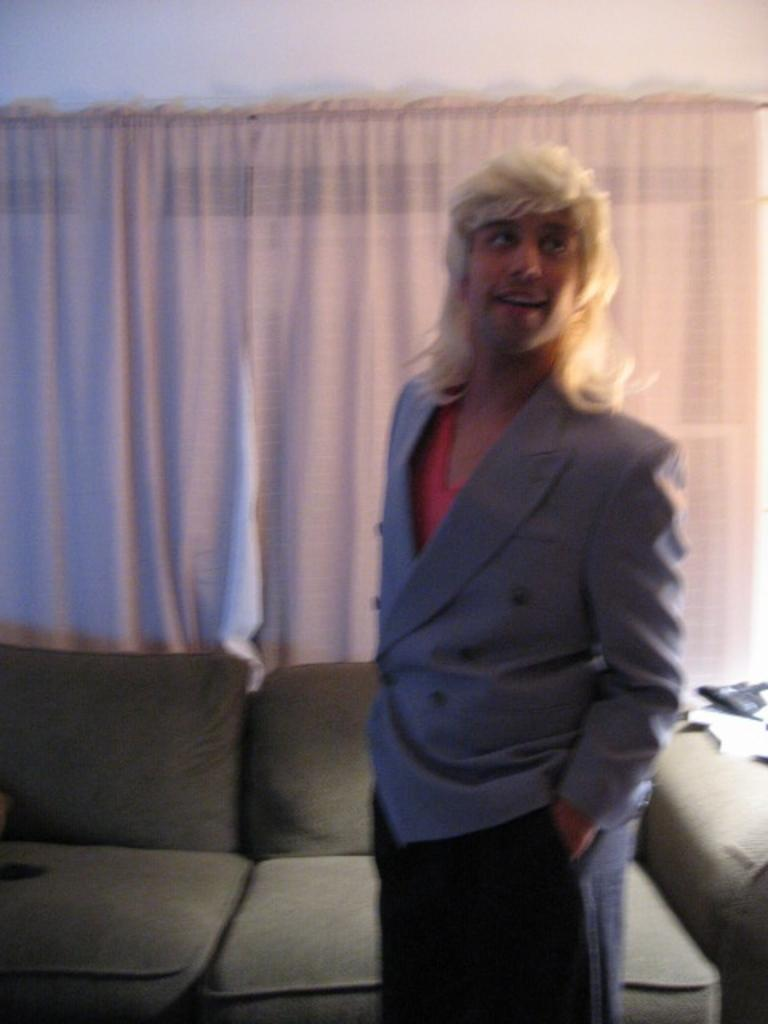What is the main subject of the image? There is a person in the image. What is the person wearing? The person is wearing a grey blazer. Where is the person located in the image? The person is standing on the floor. What can be seen in the background of the image? There are sofas, curtains, and a white wall in the background of the image. What type of store can be seen in the background of the image? There is no store visible in the background of the image. Is the person shaking hands with someone in the image? There is no indication of a handshake or any other interaction with another person in the image. 